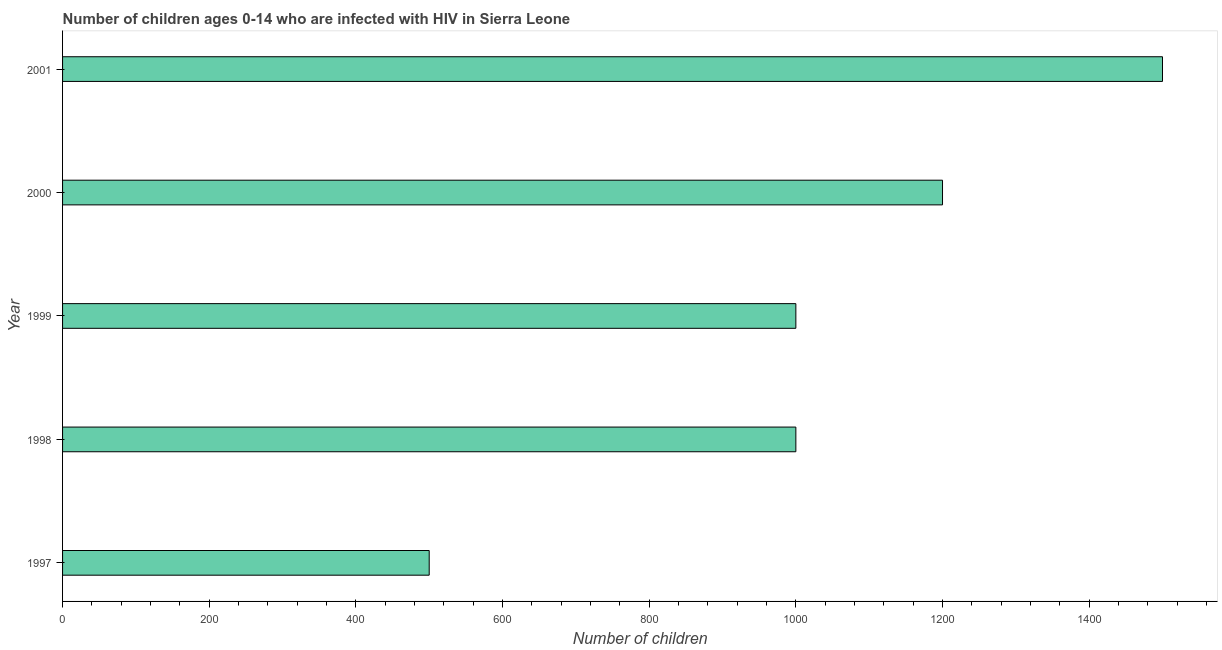Does the graph contain any zero values?
Your response must be concise. No. Does the graph contain grids?
Keep it short and to the point. No. What is the title of the graph?
Your answer should be compact. Number of children ages 0-14 who are infected with HIV in Sierra Leone. What is the label or title of the X-axis?
Your answer should be compact. Number of children. What is the label or title of the Y-axis?
Your answer should be compact. Year. What is the number of children living with hiv in 2000?
Your answer should be very brief. 1200. Across all years, what is the maximum number of children living with hiv?
Your answer should be compact. 1500. In which year was the number of children living with hiv maximum?
Provide a short and direct response. 2001. In which year was the number of children living with hiv minimum?
Make the answer very short. 1997. What is the sum of the number of children living with hiv?
Provide a succinct answer. 5200. What is the difference between the number of children living with hiv in 1998 and 2001?
Provide a succinct answer. -500. What is the average number of children living with hiv per year?
Provide a short and direct response. 1040. Do a majority of the years between 2000 and 2001 (inclusive) have number of children living with hiv greater than 1400 ?
Offer a terse response. No. What is the ratio of the number of children living with hiv in 1998 to that in 1999?
Give a very brief answer. 1. Is the number of children living with hiv in 1998 less than that in 1999?
Give a very brief answer. No. What is the difference between the highest and the second highest number of children living with hiv?
Make the answer very short. 300. Is the sum of the number of children living with hiv in 1997 and 1999 greater than the maximum number of children living with hiv across all years?
Provide a short and direct response. No. What is the difference between the highest and the lowest number of children living with hiv?
Give a very brief answer. 1000. Are the values on the major ticks of X-axis written in scientific E-notation?
Ensure brevity in your answer.  No. What is the Number of children of 2000?
Provide a short and direct response. 1200. What is the Number of children of 2001?
Offer a very short reply. 1500. What is the difference between the Number of children in 1997 and 1998?
Ensure brevity in your answer.  -500. What is the difference between the Number of children in 1997 and 1999?
Make the answer very short. -500. What is the difference between the Number of children in 1997 and 2000?
Your answer should be very brief. -700. What is the difference between the Number of children in 1997 and 2001?
Keep it short and to the point. -1000. What is the difference between the Number of children in 1998 and 1999?
Offer a very short reply. 0. What is the difference between the Number of children in 1998 and 2000?
Keep it short and to the point. -200. What is the difference between the Number of children in 1998 and 2001?
Make the answer very short. -500. What is the difference between the Number of children in 1999 and 2000?
Your answer should be compact. -200. What is the difference between the Number of children in 1999 and 2001?
Offer a terse response. -500. What is the difference between the Number of children in 2000 and 2001?
Ensure brevity in your answer.  -300. What is the ratio of the Number of children in 1997 to that in 1998?
Your response must be concise. 0.5. What is the ratio of the Number of children in 1997 to that in 2000?
Your answer should be very brief. 0.42. What is the ratio of the Number of children in 1997 to that in 2001?
Keep it short and to the point. 0.33. What is the ratio of the Number of children in 1998 to that in 1999?
Ensure brevity in your answer.  1. What is the ratio of the Number of children in 1998 to that in 2000?
Offer a very short reply. 0.83. What is the ratio of the Number of children in 1998 to that in 2001?
Ensure brevity in your answer.  0.67. What is the ratio of the Number of children in 1999 to that in 2000?
Keep it short and to the point. 0.83. What is the ratio of the Number of children in 1999 to that in 2001?
Keep it short and to the point. 0.67. What is the ratio of the Number of children in 2000 to that in 2001?
Provide a succinct answer. 0.8. 